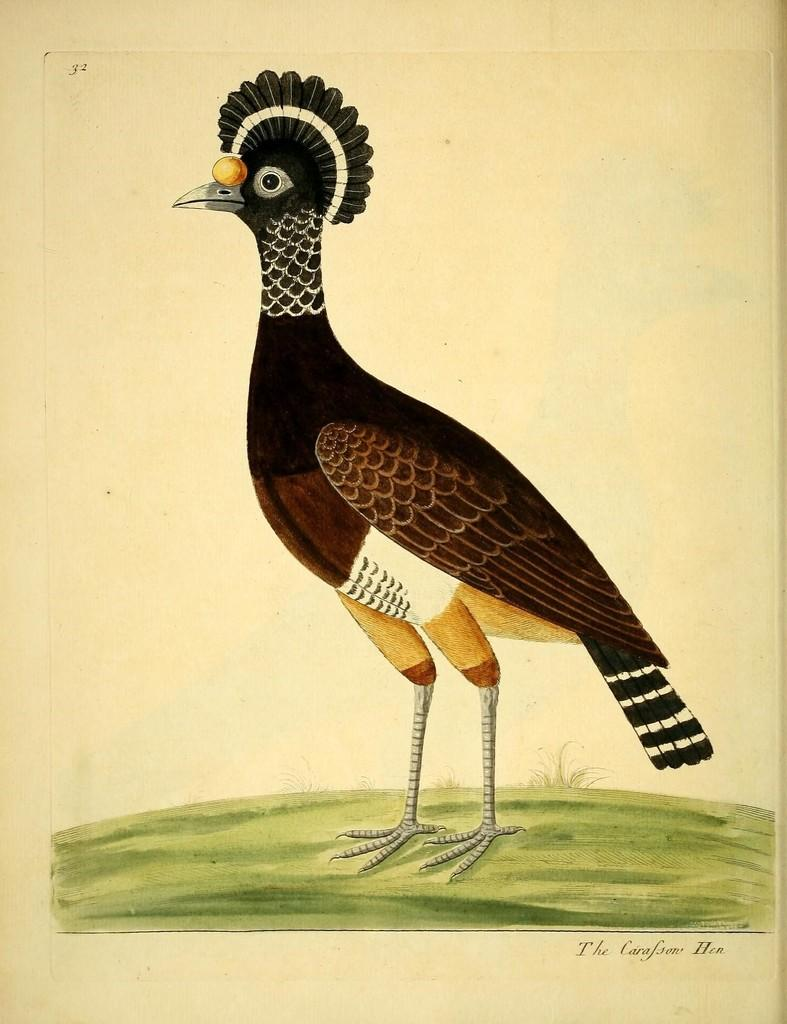What is the main subject of the image? The image contains a painting. What is depicted in the painting? The painting depicts a bird. How is the bird described in the painting? The bird is described as beautiful. What is the bird standing on in the painting? The bird is standing on the grass in the painting. How do the snails compare to the bird in the painting? There are no snails present in the painting, so it is not possible to make a comparison. 